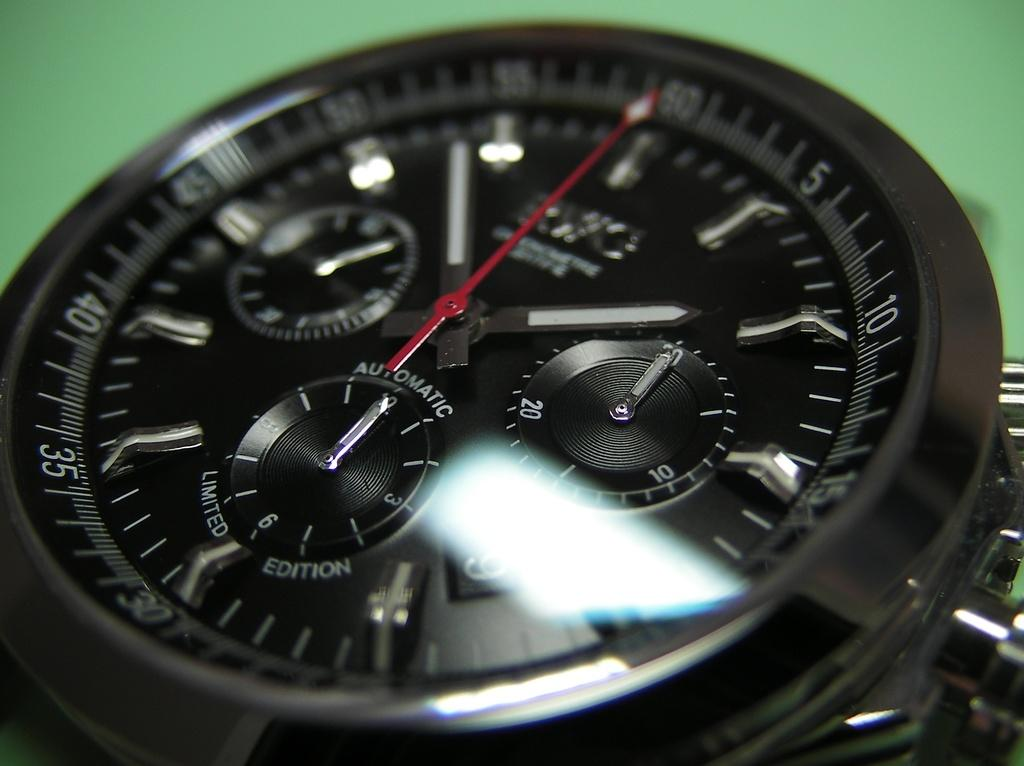<image>
Summarize the visual content of the image. A black limited edition watch has a red second hand. 